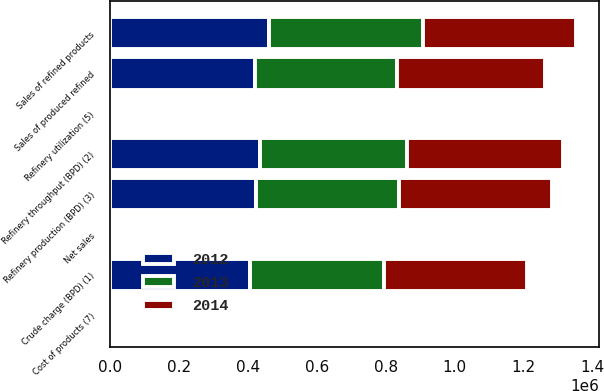Convert chart to OTSL. <chart><loc_0><loc_0><loc_500><loc_500><stacked_bar_chart><ecel><fcel>Crude charge (BPD) (1)<fcel>Refinery throughput (BPD) (2)<fcel>Refinery production (BPD) (3)<fcel>Sales of produced refined<fcel>Sales of refined products<fcel>Refinery utilization (5)<fcel>Net sales<fcel>Cost of products (7)<nl><fcel>2012<fcel>406180<fcel>436400<fcel>425010<fcel>420990<fcel>461640<fcel>91.7<fcel>110.19<fcel>96.21<nl><fcel>2013<fcel>387520<fcel>424780<fcel>413820<fcel>410730<fcel>446390<fcel>87.5<fcel>115.6<fcel>99.61<nl><fcel>2014<fcel>415210<fcel>453740<fcel>442730<fcel>431060<fcel>443620<fcel>93.7<fcel>119.48<fcel>94.59<nl></chart> 